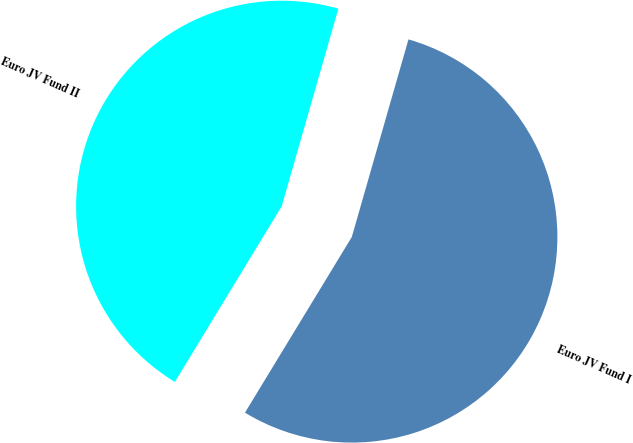Convert chart to OTSL. <chart><loc_0><loc_0><loc_500><loc_500><pie_chart><fcel>Euro JV Fund I<fcel>Euro JV Fund II<nl><fcel>54.25%<fcel>45.75%<nl></chart> 